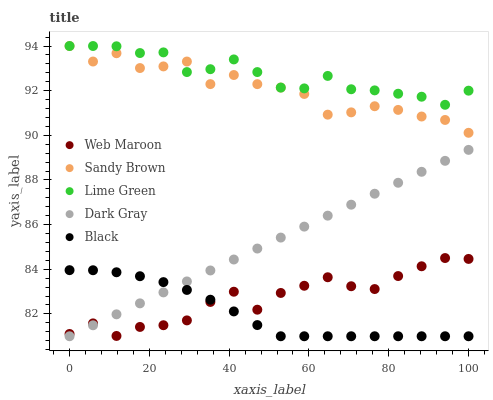Does Black have the minimum area under the curve?
Answer yes or no. Yes. Does Lime Green have the maximum area under the curve?
Answer yes or no. Yes. Does Sandy Brown have the minimum area under the curve?
Answer yes or no. No. Does Sandy Brown have the maximum area under the curve?
Answer yes or no. No. Is Dark Gray the smoothest?
Answer yes or no. Yes. Is Sandy Brown the roughest?
Answer yes or no. Yes. Is Web Maroon the smoothest?
Answer yes or no. No. Is Web Maroon the roughest?
Answer yes or no. No. Does Dark Gray have the lowest value?
Answer yes or no. Yes. Does Sandy Brown have the lowest value?
Answer yes or no. No. Does Lime Green have the highest value?
Answer yes or no. Yes. Does Web Maroon have the highest value?
Answer yes or no. No. Is Dark Gray less than Sandy Brown?
Answer yes or no. Yes. Is Sandy Brown greater than Web Maroon?
Answer yes or no. Yes. Does Web Maroon intersect Black?
Answer yes or no. Yes. Is Web Maroon less than Black?
Answer yes or no. No. Is Web Maroon greater than Black?
Answer yes or no. No. Does Dark Gray intersect Sandy Brown?
Answer yes or no. No. 